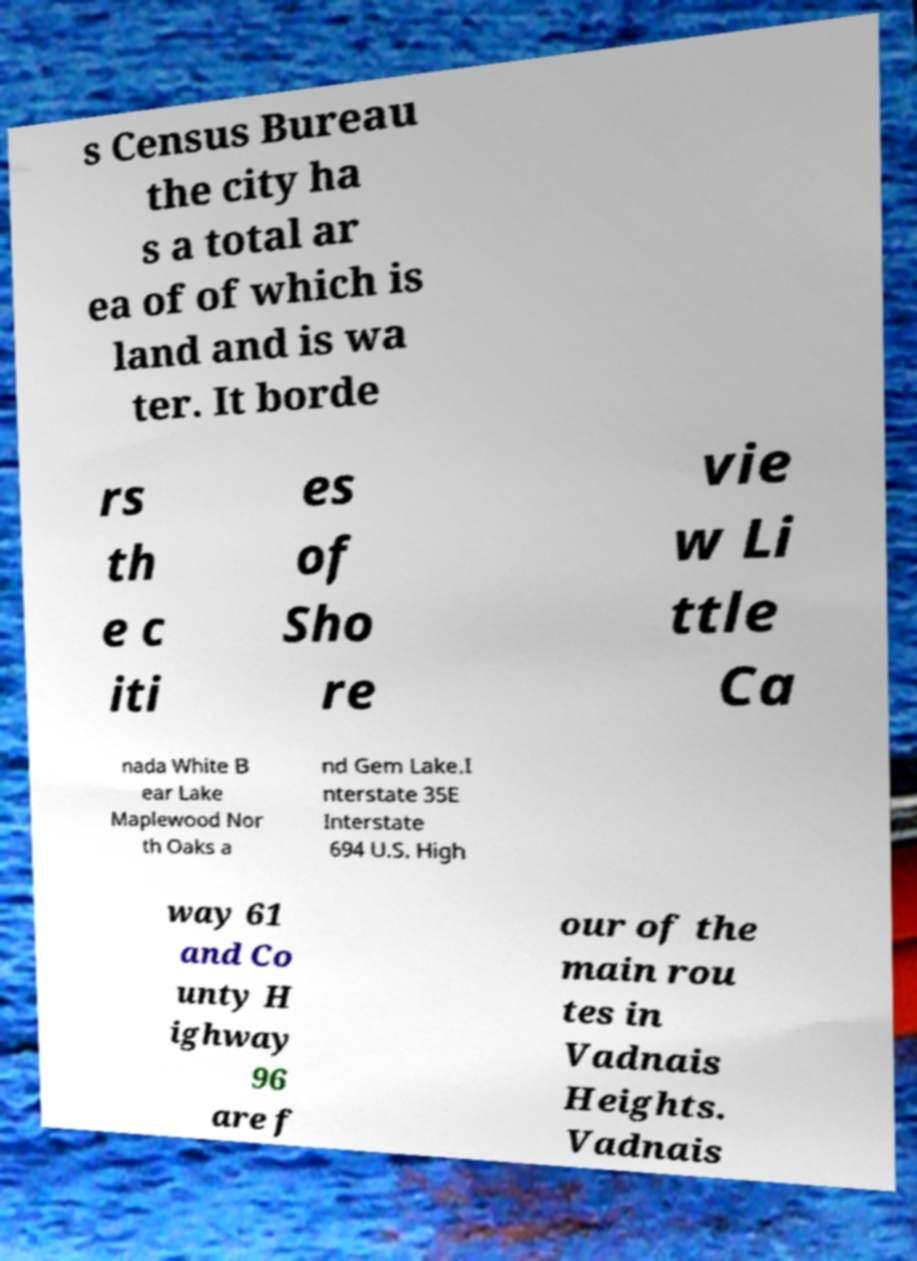I need the written content from this picture converted into text. Can you do that? s Census Bureau the city ha s a total ar ea of of which is land and is wa ter. It borde rs th e c iti es of Sho re vie w Li ttle Ca nada White B ear Lake Maplewood Nor th Oaks a nd Gem Lake.I nterstate 35E Interstate 694 U.S. High way 61 and Co unty H ighway 96 are f our of the main rou tes in Vadnais Heights. Vadnais 